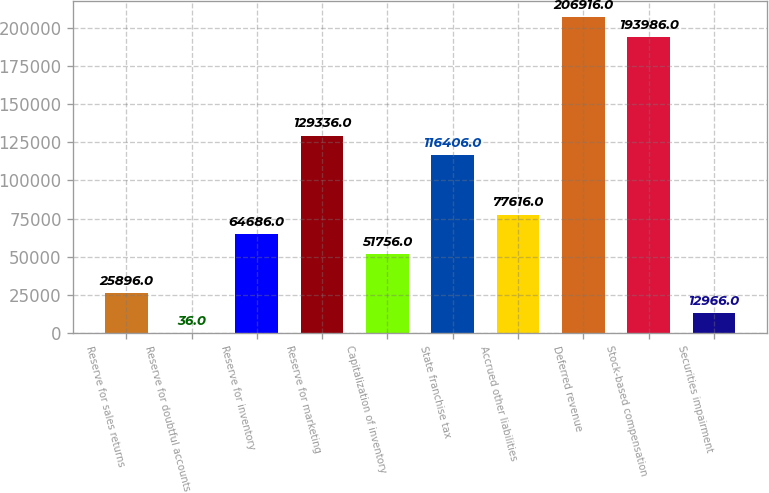Convert chart to OTSL. <chart><loc_0><loc_0><loc_500><loc_500><bar_chart><fcel>Reserve for sales returns<fcel>Reserve for doubtful accounts<fcel>Reserve for inventory<fcel>Reserve for marketing<fcel>Capitalization of inventory<fcel>State franchise tax<fcel>Accrued other liabilities<fcel>Deferred revenue<fcel>Stock-based compensation<fcel>Securities impairment<nl><fcel>25896<fcel>36<fcel>64686<fcel>129336<fcel>51756<fcel>116406<fcel>77616<fcel>206916<fcel>193986<fcel>12966<nl></chart> 